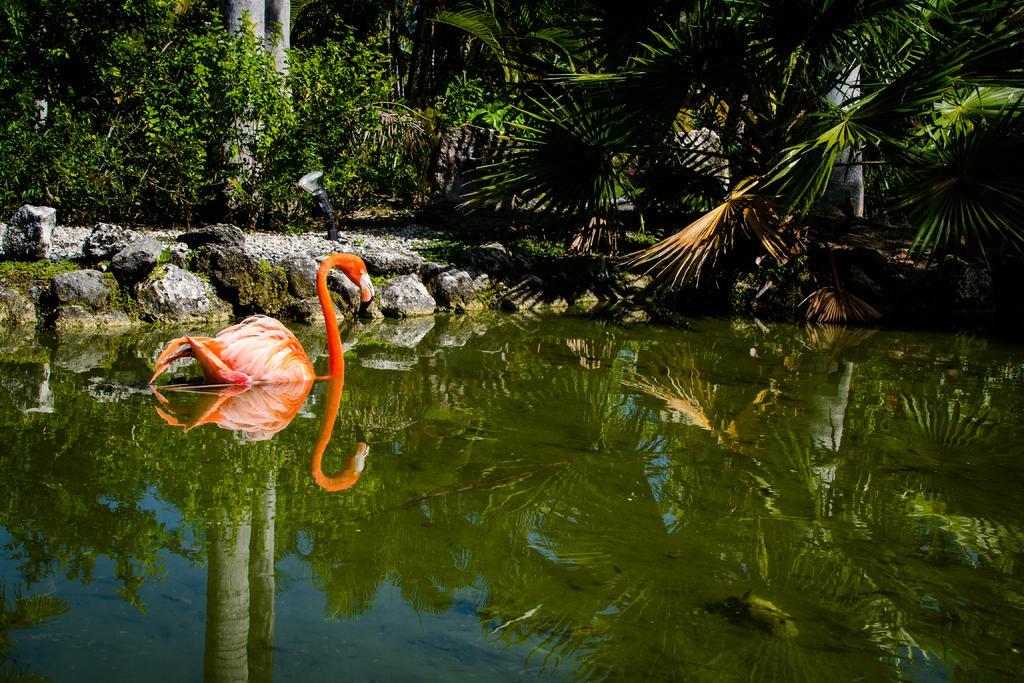Could you give a brief overview of what you see in this image? In this image we can see a bird on the surface of water. In the background of the image, we can see greenery and rocky land. 